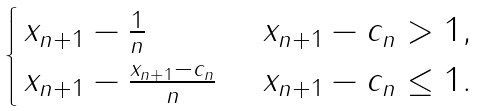<formula> <loc_0><loc_0><loc_500><loc_500>\begin{cases} \, x _ { n + 1 } - \frac { 1 } { n } \quad \, \quad & \, x _ { n + 1 } - c _ { n } > 1 , \\ \, x _ { n + 1 } - \frac { x _ { n + 1 } - c _ { n } } { n } & \, x _ { n + 1 } - c _ { n } \leq 1 . \end{cases}</formula> 